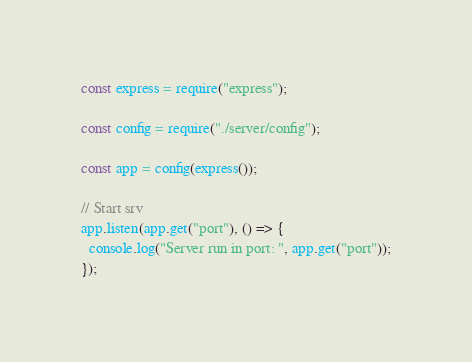Convert code to text. <code><loc_0><loc_0><loc_500><loc_500><_JavaScript_>const express = require("express");

const config = require("./server/config");

const app = config(express());

// Start srv
app.listen(app.get("port"), () => {
  console.log("Server run in port: ", app.get("port"));
});
</code> 